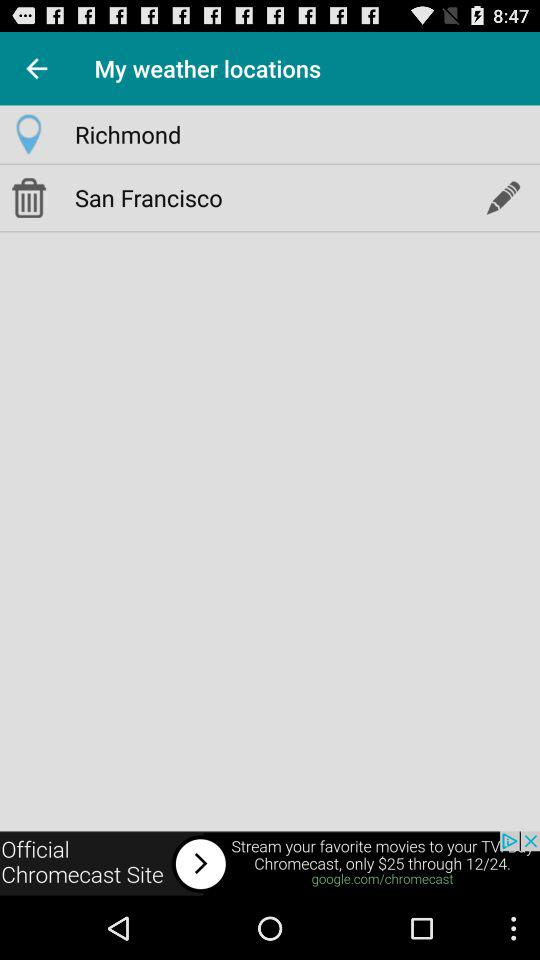What is the current location set to? The current location is set to Richmond. 